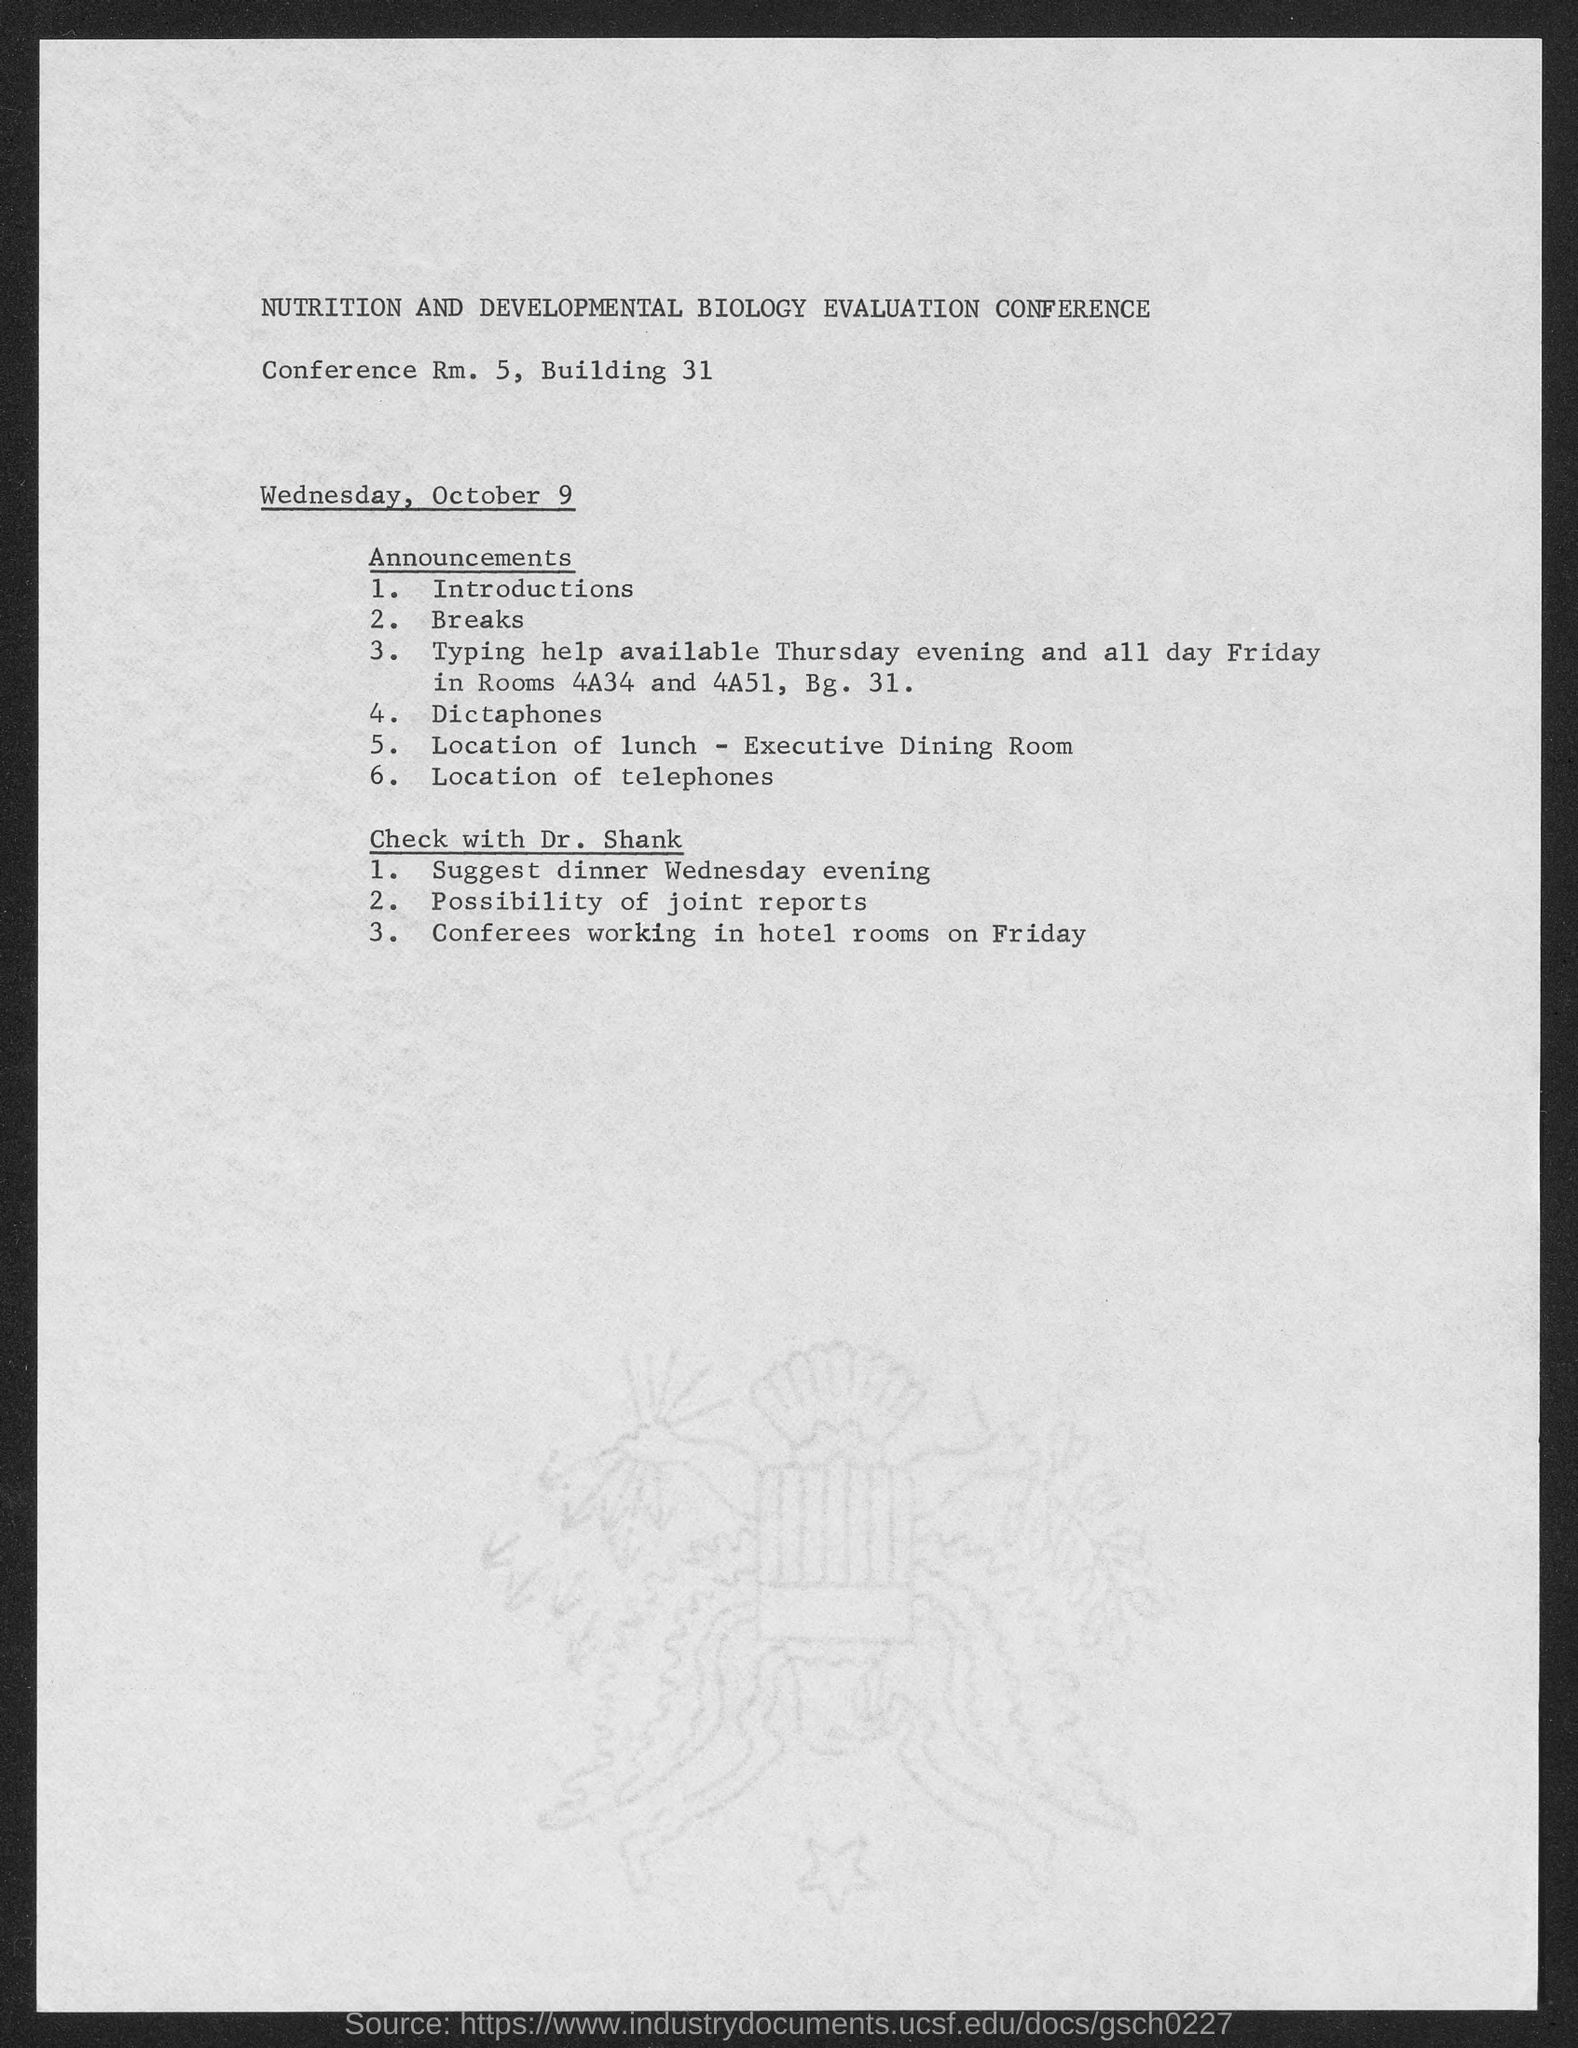Outline some significant characteristics in this image. The conference started on Wednesday, October 9th. 